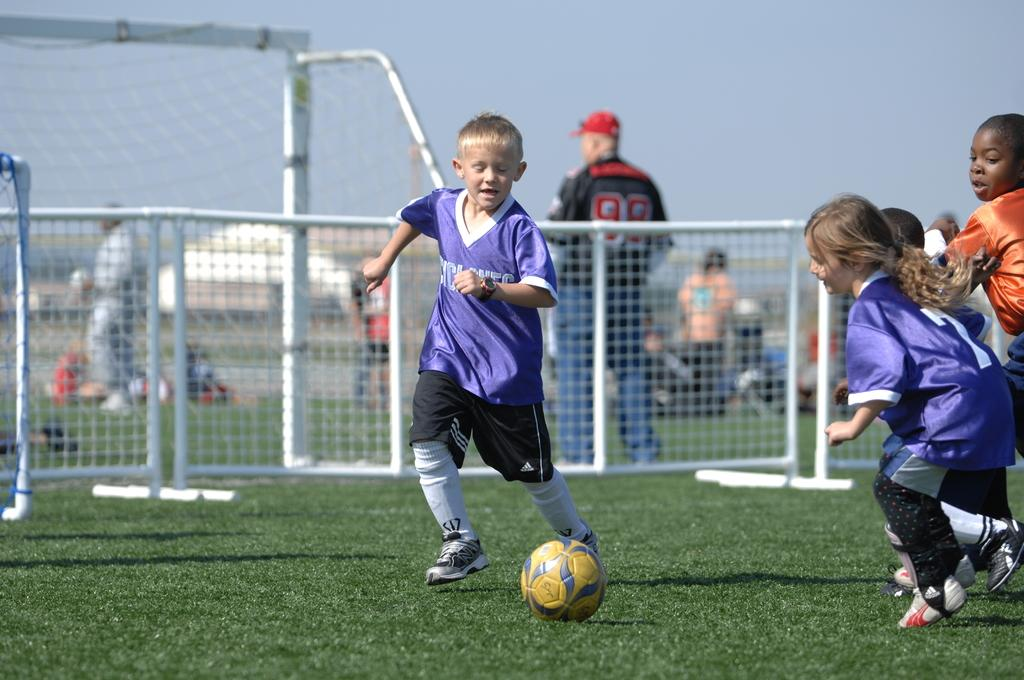Who is present in the image? There are children in the image. What object is visible in the image that is commonly used in sports? There is a football in the image. What type of structure can be seen in the image? There is a gate in the image. What is the purpose of the goal post in the image? The goal post is used in the game of football. What type of story is being told by the children in the image? There is no indication in the image that the children are telling a story. 